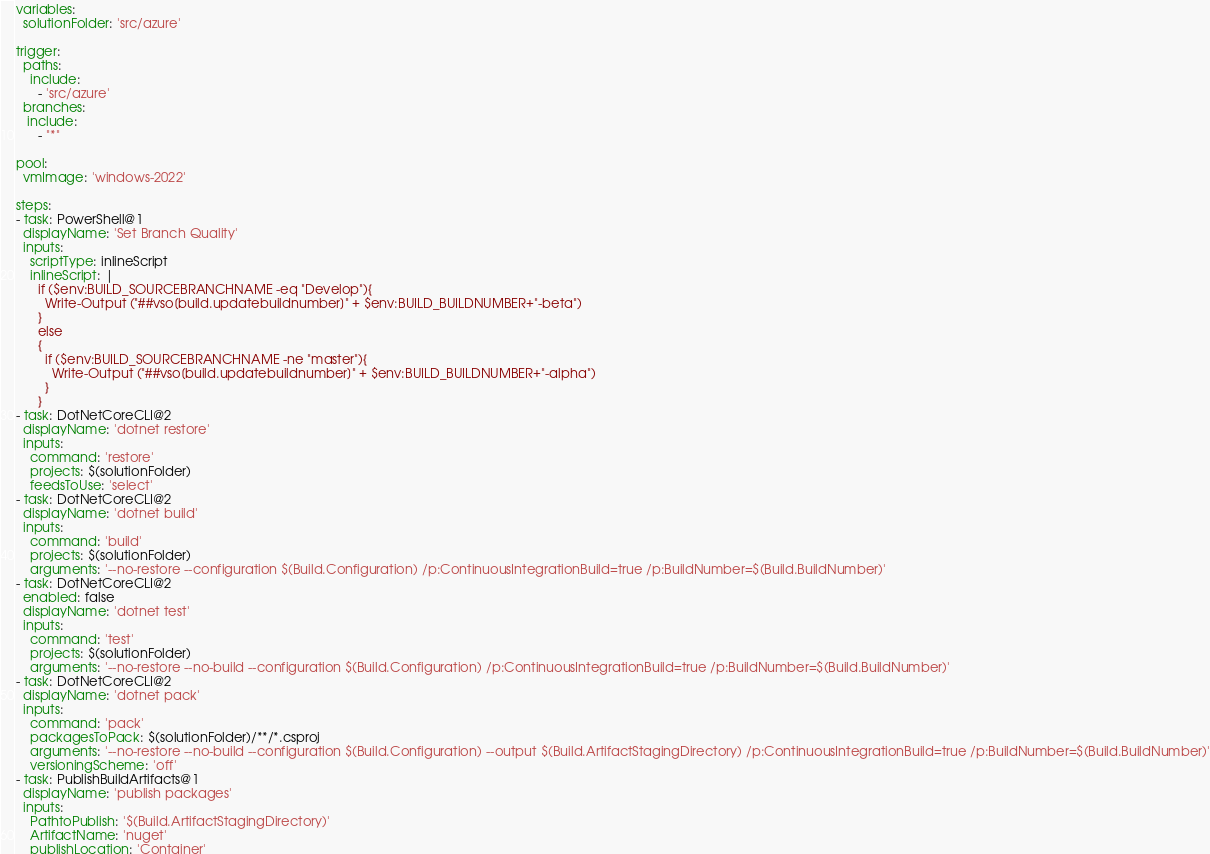<code> <loc_0><loc_0><loc_500><loc_500><_YAML_>variables:
  solutionFolder: 'src/azure'

trigger:
  paths:
    include:
      - 'src/azure'
  branches:
   include:
      - "*"

pool:
  vmImage: 'windows-2022'

steps:
- task: PowerShell@1
  displayName: 'Set Branch Quality'
  inputs:
    scriptType: inlineScript
    inlineScript: |
      if ($env:BUILD_SOURCEBRANCHNAME -eq "Develop"){
        Write-Output ("##vso[build.updatebuildnumber]" + $env:BUILD_BUILDNUMBER+"-beta")
      }
      else 
      {
        if ($env:BUILD_SOURCEBRANCHNAME -ne "master"){
          Write-Output ("##vso[build.updatebuildnumber]" + $env:BUILD_BUILDNUMBER+"-alpha")
        }
      }
- task: DotNetCoreCLI@2
  displayName: 'dotnet restore'
  inputs:
    command: 'restore'
    projects: $(solutionFolder)
    feedsToUse: 'select'
- task: DotNetCoreCLI@2
  displayName: 'dotnet build'
  inputs:
    command: 'build'
    projects: $(solutionFolder)
    arguments: '--no-restore --configuration $(Build.Configuration) /p:ContinuousIntegrationBuild=true /p:BuildNumber=$(Build.BuildNumber)'
- task: DotNetCoreCLI@2
  enabled: false
  displayName: 'dotnet test'
  inputs:
    command: 'test'
    projects: $(solutionFolder)
    arguments: '--no-restore --no-build --configuration $(Build.Configuration) /p:ContinuousIntegrationBuild=true /p:BuildNumber=$(Build.BuildNumber)'
- task: DotNetCoreCLI@2
  displayName: 'dotnet pack'
  inputs:
    command: 'pack'
    packagesToPack: $(solutionFolder)/**/*.csproj
    arguments: '--no-restore --no-build --configuration $(Build.Configuration) --output $(Build.ArtifactStagingDirectory) /p:ContinuousIntegrationBuild=true /p:BuildNumber=$(Build.BuildNumber)'
    versioningScheme: 'off'
- task: PublishBuildArtifacts@1
  displayName: 'publish packages'
  inputs:
    PathtoPublish: '$(Build.ArtifactStagingDirectory)'
    ArtifactName: 'nuget'
    publishLocation: 'Container'
</code> 